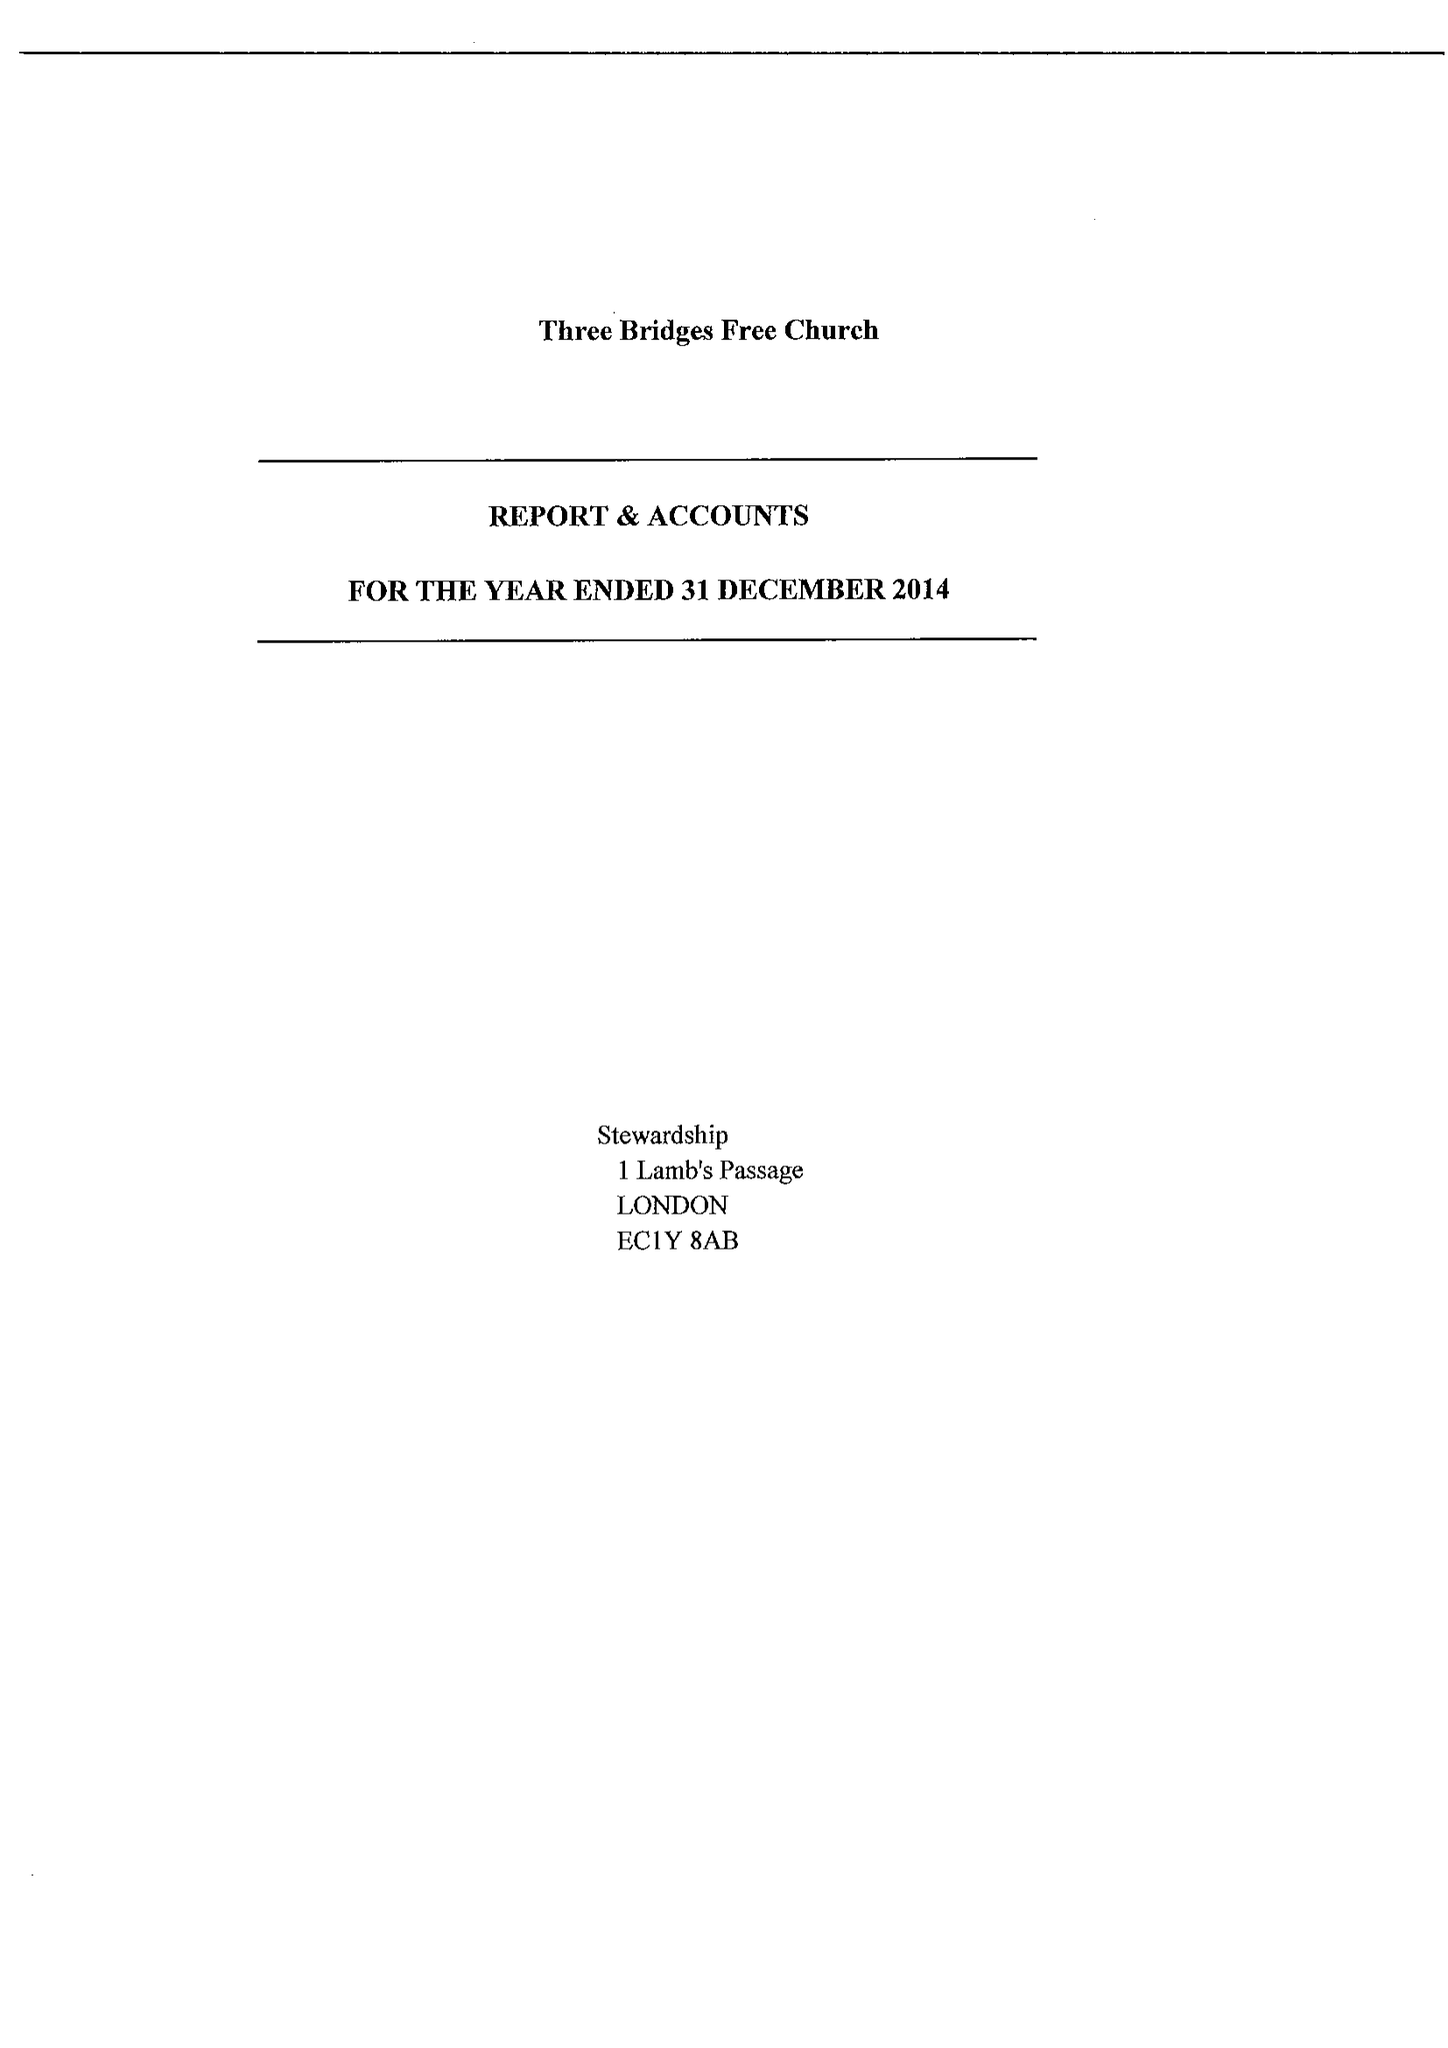What is the value for the spending_annually_in_british_pounds?
Answer the question using a single word or phrase. 100367.00 